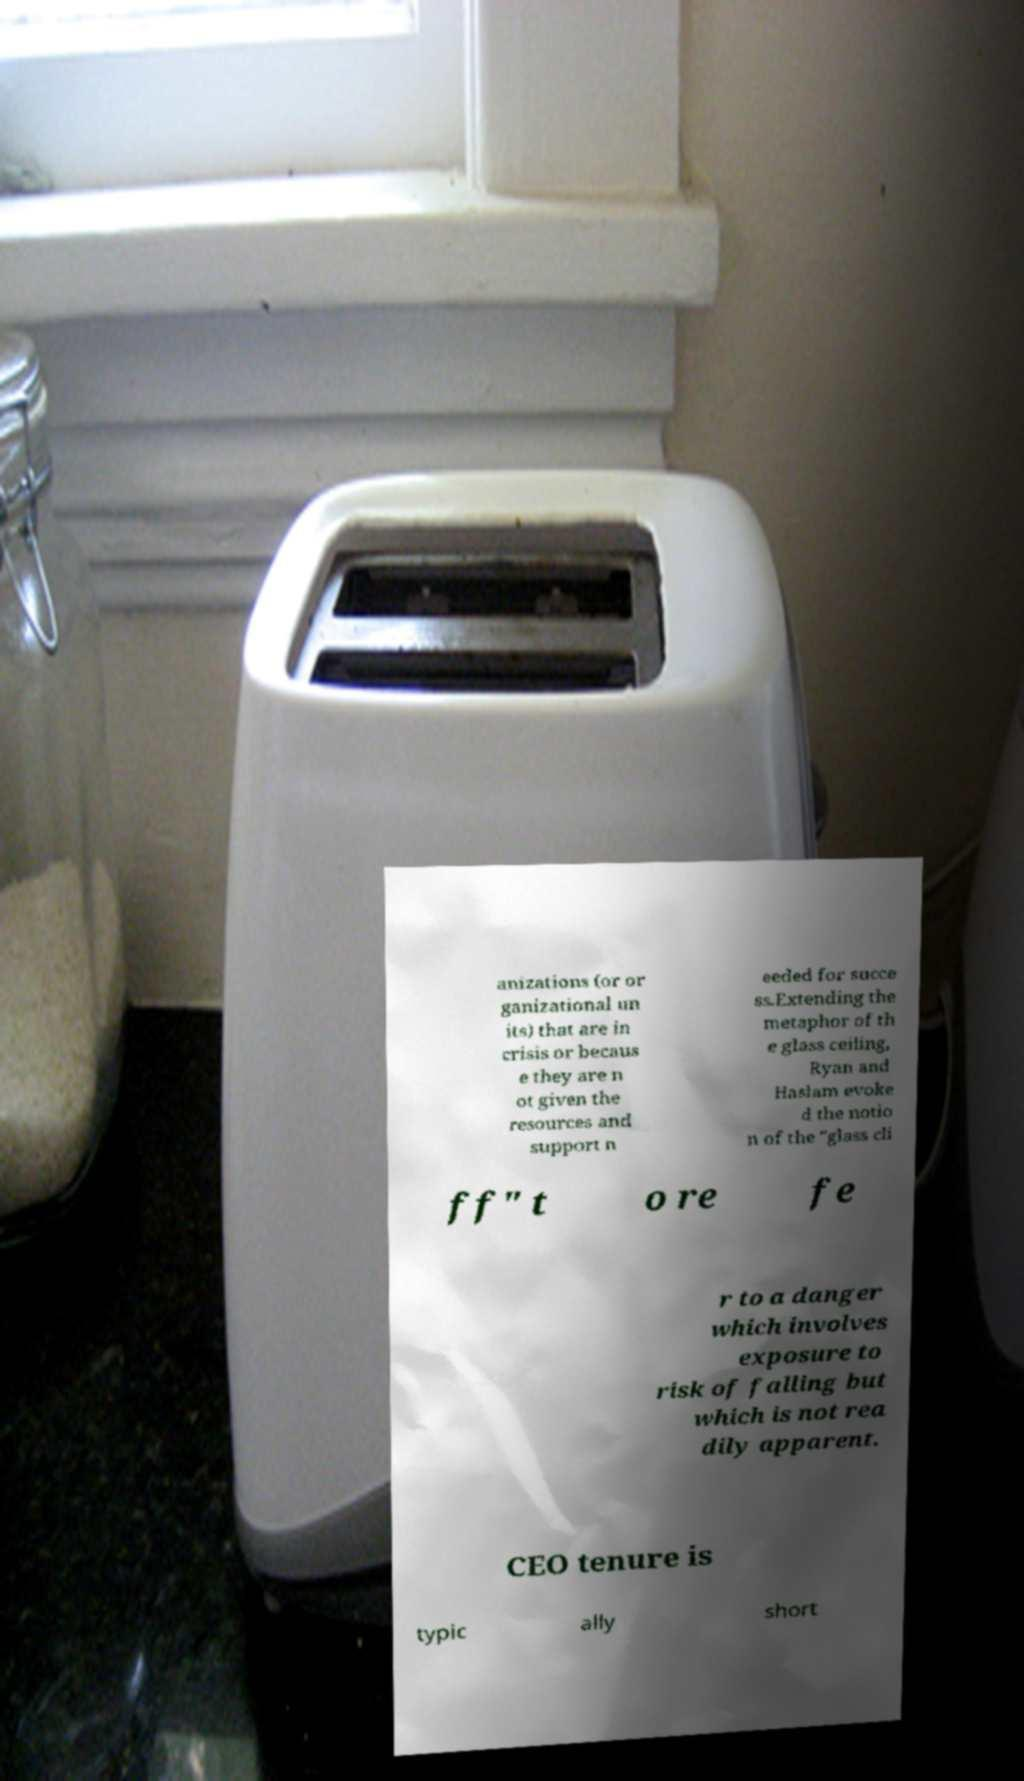Please identify and transcribe the text found in this image. anizations (or or ganizational un its) that are in crisis or becaus e they are n ot given the resources and support n eeded for succe ss.Extending the metaphor of th e glass ceiling, Ryan and Haslam evoke d the notio n of the "glass cli ff" t o re fe r to a danger which involves exposure to risk of falling but which is not rea dily apparent. CEO tenure is typic ally short 